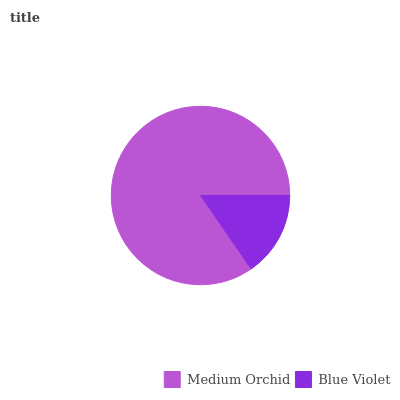Is Blue Violet the minimum?
Answer yes or no. Yes. Is Medium Orchid the maximum?
Answer yes or no. Yes. Is Blue Violet the maximum?
Answer yes or no. No. Is Medium Orchid greater than Blue Violet?
Answer yes or no. Yes. Is Blue Violet less than Medium Orchid?
Answer yes or no. Yes. Is Blue Violet greater than Medium Orchid?
Answer yes or no. No. Is Medium Orchid less than Blue Violet?
Answer yes or no. No. Is Medium Orchid the high median?
Answer yes or no. Yes. Is Blue Violet the low median?
Answer yes or no. Yes. Is Blue Violet the high median?
Answer yes or no. No. Is Medium Orchid the low median?
Answer yes or no. No. 